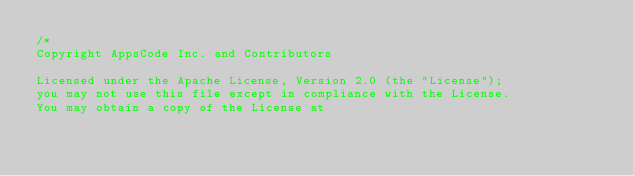Convert code to text. <code><loc_0><loc_0><loc_500><loc_500><_Go_>/*
Copyright AppsCode Inc. and Contributors

Licensed under the Apache License, Version 2.0 (the "License");
you may not use this file except in compliance with the License.
You may obtain a copy of the License at
</code> 